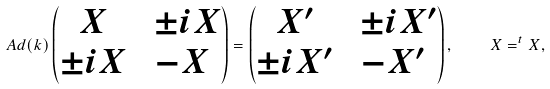Convert formula to latex. <formula><loc_0><loc_0><loc_500><loc_500>A d ( k ) \begin{pmatrix} X & \ \pm i X \\ \pm i X & - X \end{pmatrix} = \begin{pmatrix} X ^ { \prime } & \ \pm i X ^ { \prime } \\ \pm i X ^ { \prime } & - X ^ { \prime } \end{pmatrix} , \quad X = ^ { t } X ,</formula> 